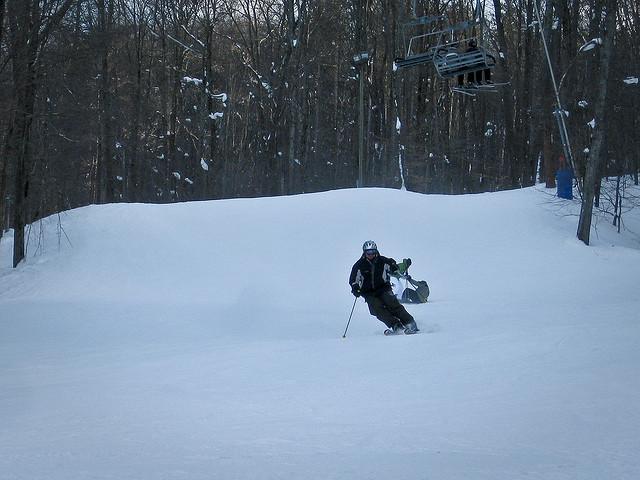Is the man going down a hill?
Quick response, please. Yes. What is the man dragging?
Concise answer only. Bag. What's in the background?
Concise answer only. Trees. What is on the ground?
Write a very short answer. Snow. 